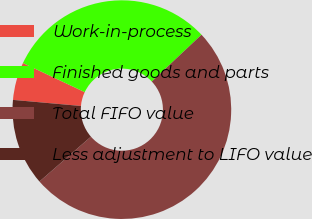Convert chart. <chart><loc_0><loc_0><loc_500><loc_500><pie_chart><fcel>Work-in-process<fcel>Finished goods and parts<fcel>Total FIFO value<fcel>Less adjustment to LIFO value<nl><fcel>5.59%<fcel>30.97%<fcel>50.6%<fcel>12.84%<nl></chart> 